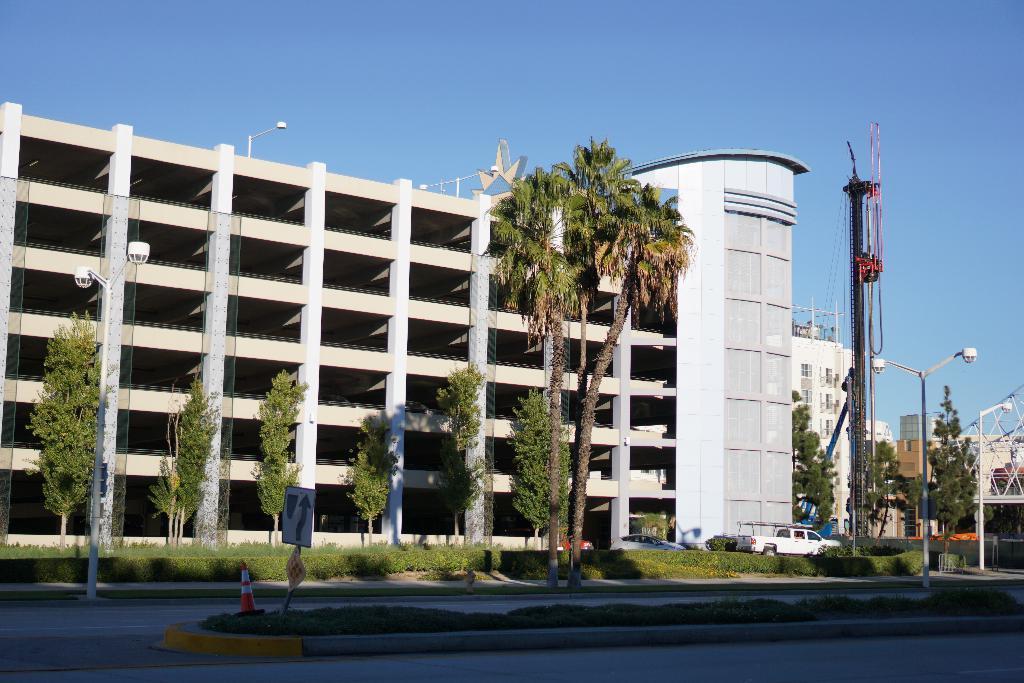Describe this image in one or two sentences. In this picture I can see buildings and few pole lights and trees and a tower and few vehicles moving on the road and I can see grass and a blue sky and I can see a sign board and a cone. 